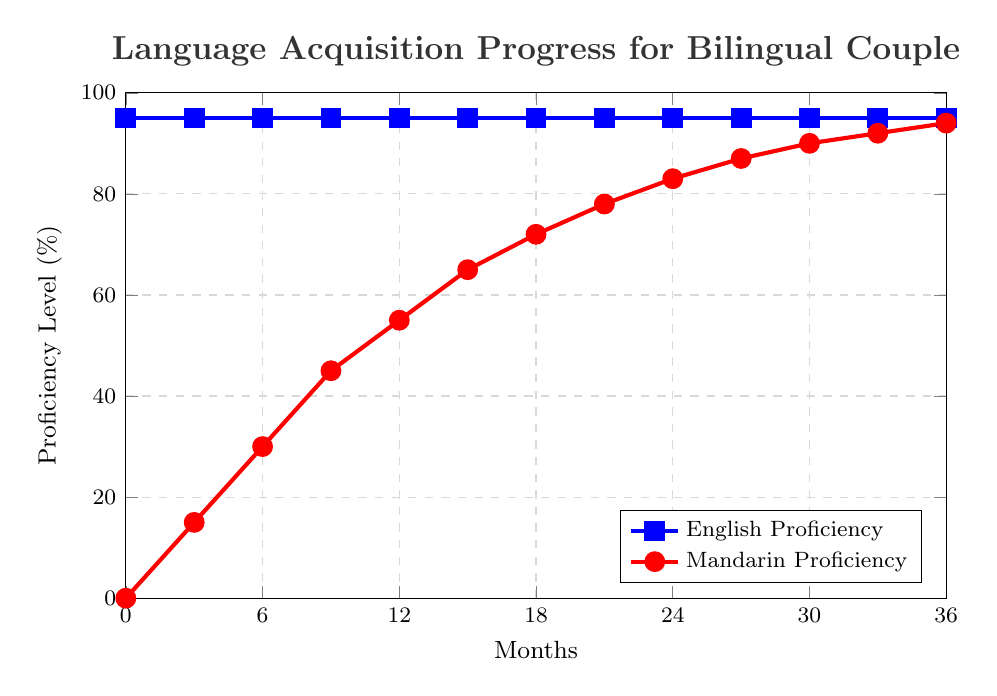What are the proficiency levels for English and Mandarin at 6 months? At the 6-month mark, follow the x-axis to 6, then read the y-values of both lines. The English proficiency is at 95%, and the Mandarin proficiency is at 30%.
Answer: English: 95%, Mandarin: 30% How much does Mandarin proficiency increase between 3 and 9 months? At 3 months, Mandarin proficiency is at 15%, and at 9 months, it is at 45%. The increase is 45% - 15% = 30%.
Answer: 30% What is the difference in proficiency levels between English and Mandarin at 12 months? At 12 months, English proficiency is 95% and Mandarin proficiency is 55%. The difference is 95% - 55% = 40%.
Answer: 40% By how much does Mandarin proficiency exceed its starting level at 24 months? The starting level of Mandarin proficiency is 0%, and at 24 months, it is 83%. So, the increase is 83% - 0% = 83%.
Answer: 83% Which language shows a linear progression in proficiency over time? By observing the slopes of the lines in the chart, the line for Mandarin proficiency shows a steady increase, indicating a linear progression. The English proficiency remains constant at 95%. Thus, Mandarin proficiency shows a linear progression.
Answer: Mandarin At what point do English and Mandarin proficiencies have the smallest difference, and what is that difference? To find the smallest difference, observe multiple points along the x-axis. At 36 months, English is 95% and Mandarin is 94%, leading to a difference of 1%. This is the smallest observed difference.
Answer: 36 months, 1% How does the slope of English proficiency compare to that of Mandarin proficiency? The slope of the English proficiency line is flat and horizontal, indicating no change. In contrast, the Mandarin proficiency line increases steadily, indicating a positive slope. This means Mandarin proficiency is increasing over time while English proficiency remains constant.
Answer: English: Flat, Mandarin: Increasing During which time period is the rate of increase in Mandarin proficiency the highest? Observe the steepest part of the Mandarin proficiency line. The steepest increase appears from 0 to 6 months (0% to 30%), indicating the highest rate of increase during this period.
Answer: 0-6 months What is the visual difference between the two lines representing language proficiency? The English proficiency line is blue and marked with square points, while the Mandarin proficiency line is red and marked with circular points.
Answer: Blue line with squares (English), Red line with circles (Mandarin) Over the span of 36 months, by how much does Mandarin proficiency increase on average each month? At 36 months, Mandarin proficiency is 94%. The increase over 36 months is 94% - 0% = 94%. To find the average increase per month, divide by the number of months: 94% / 36 ≈ 2.61%.
Answer: About 2.61% per month 